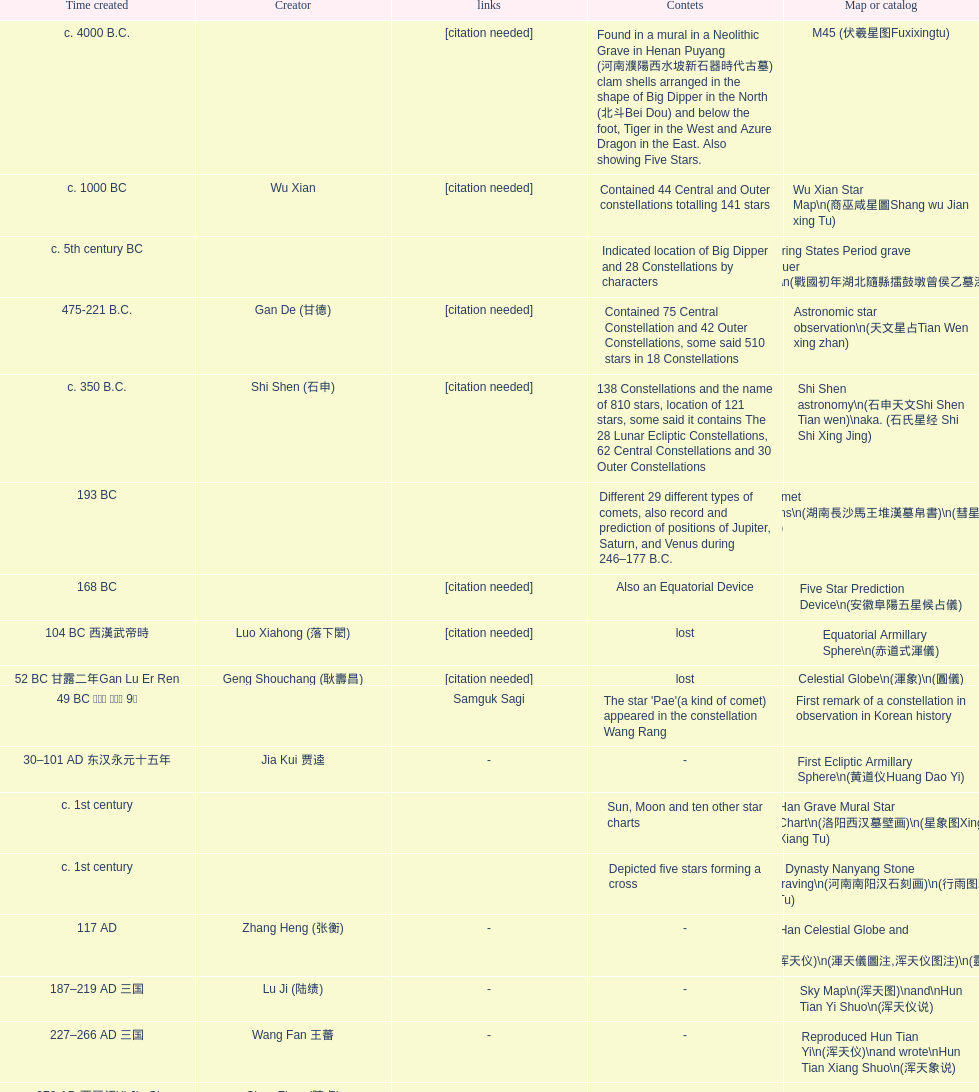When was the first map or catalog created? C. 4000 b.c. 